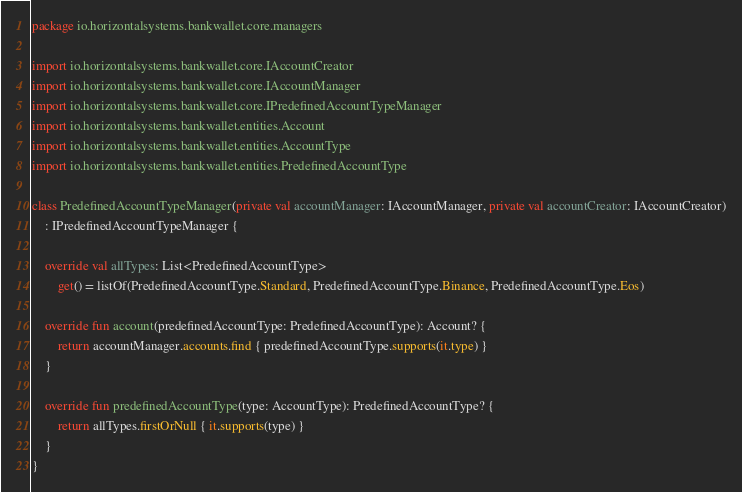Convert code to text. <code><loc_0><loc_0><loc_500><loc_500><_Kotlin_>package io.horizontalsystems.bankwallet.core.managers

import io.horizontalsystems.bankwallet.core.IAccountCreator
import io.horizontalsystems.bankwallet.core.IAccountManager
import io.horizontalsystems.bankwallet.core.IPredefinedAccountTypeManager
import io.horizontalsystems.bankwallet.entities.Account
import io.horizontalsystems.bankwallet.entities.AccountType
import io.horizontalsystems.bankwallet.entities.PredefinedAccountType

class PredefinedAccountTypeManager(private val accountManager: IAccountManager, private val accountCreator: IAccountCreator)
    : IPredefinedAccountTypeManager {

    override val allTypes: List<PredefinedAccountType>
        get() = listOf(PredefinedAccountType.Standard, PredefinedAccountType.Binance, PredefinedAccountType.Eos)

    override fun account(predefinedAccountType: PredefinedAccountType): Account? {
        return accountManager.accounts.find { predefinedAccountType.supports(it.type) }
    }

    override fun predefinedAccountType(type: AccountType): PredefinedAccountType? {
        return allTypes.firstOrNull { it.supports(type) }
    }
}
</code> 